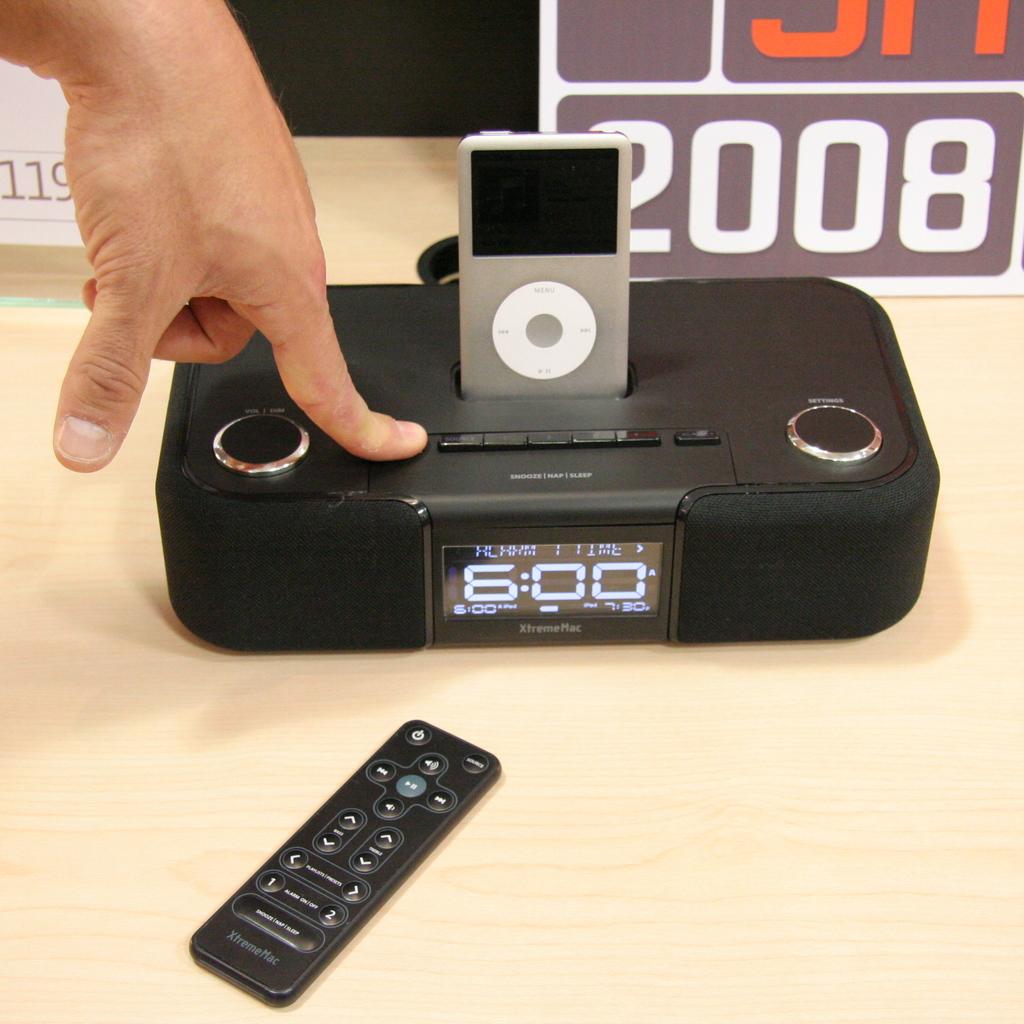What time does the clock say?
Ensure brevity in your answer.  6:00. 